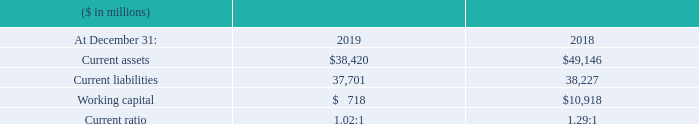IBM Working Capital
Working capital decreased $10,200 million from the year-end
2018 position. The key changes are described below:
Current assets decreased $10,726 million ($10,477 million adjusted for currency) due to: • A decline in receivables of $6,769 million ($6,695 million adjusted for currency) driven by a decline in financing receivables of $8,197 million primarily due to the wind down of OEM IT commercial financing operations; partially offset by an increase in other receivables of $989 million primarily related to divestitures; and • A decrease of $3,213 million ($3,052 million adjusted for currency) in cash and cash equivalents, restricted cash, and marketable securities primarily due to retirement of debt.
Current liabilities decreased $526 million ($449 million adjusted
for currency) as a result of:
• A decrease in accounts payable of $1,662 million primarily due to the wind down of OEM IT commercial financing operations; and • A decrease in short-term debt of $1,410 million due to maturities of $12,649 million and a decrease in commercial paper of $2,691 million; partially offset by reclassifications of $7,592 million from long-term debt to reflect upcoming maturities and issuances of $6,334 million; offset by • An increase in operating lease liabilities of $1,380 million as a result of the adoption of the new leasing standard on January 1, 2019; and • An increase in deferred income of $861 million ($890 million adjusted for currency).
What was the decrease in Working capital from 2018? $10,200 million. What caused the current assets to decrease? A decline in receivables of $6,769 million ($6,695 million adjusted for currency) driven by a decline in financing receivables of $8,197 million primarily due to the wind down of oem it commercial financing operations; partially offset by an increase in other receivables of $989 million primarily related to divestitures; and • a decrease of $3,213 million ($3,052 million adjusted for currency) in cash and cash equivalents, restricted cash, and marketable securities primarily due to retirement of debt. What caused the current liabilities to decrease? • a decrease in accounts payable of $1,662 million primarily due to the wind down of oem it commercial financing operations; and • a decrease in short-term debt of $1,410 million due to maturities of $12,649 million and a decrease in commercial paper of $2,691 million; partially offset by reclassifications of $7,592 million from long-term debt to reflect upcoming maturities and issuances of $6,334 million; offset by • an increase in operating lease liabilities of $1,380 million as a result of the adoption of the new leasing standard on january 1, 2019; and • an increase in deferred income of $861 million ($890 million adjusted for currency). What was the increase / (decrease) in the current assets from 2018 to 2019?
Answer scale should be: million. 38,420 - 49,146
Answer: -10726. What is the percentage increase / (decrease) in Current liabilities from 2018 to 2019?
Answer scale should be: percent. 37,701/38,227 - 1
Answer: -1.38. What is the average working capital?
Answer scale should be: million. (718 + 10,918) / 2
Answer: 5818. 